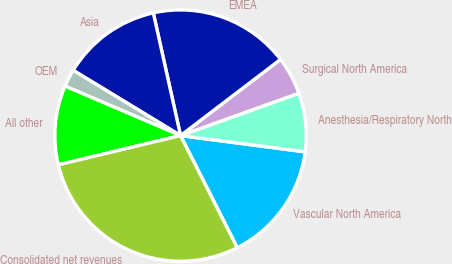Convert chart. <chart><loc_0><loc_0><loc_500><loc_500><pie_chart><fcel>Vascular North America<fcel>Anesthesia/Respiratory North<fcel>Surgical North America<fcel>EMEA<fcel>Asia<fcel>OEM<fcel>All other<fcel>Consolidated net revenues<nl><fcel>15.48%<fcel>7.54%<fcel>4.89%<fcel>18.12%<fcel>12.83%<fcel>2.25%<fcel>10.18%<fcel>28.71%<nl></chart> 